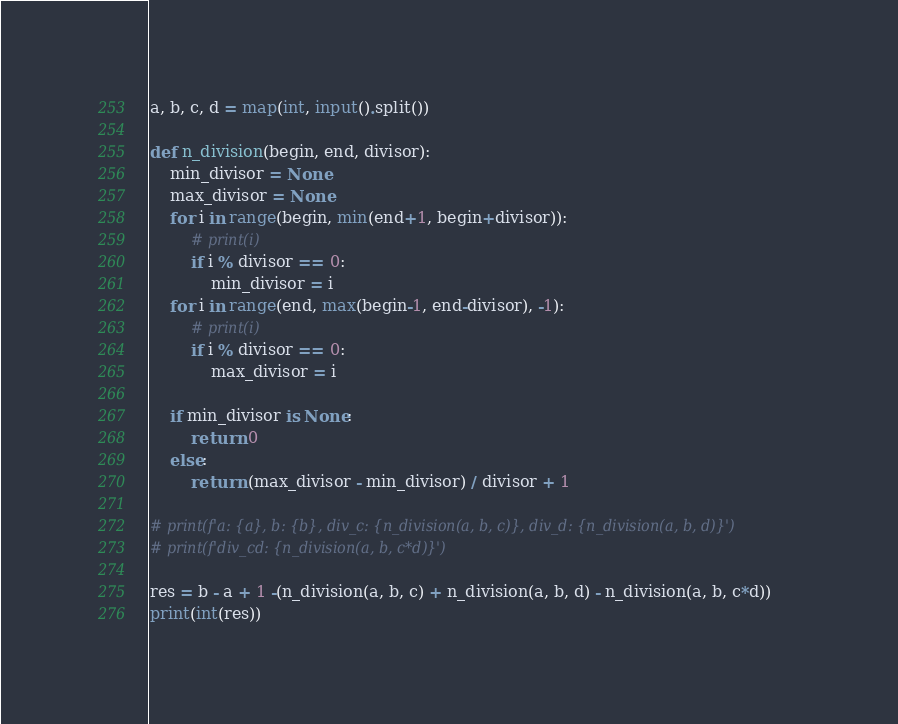Convert code to text. <code><loc_0><loc_0><loc_500><loc_500><_Python_>a, b, c, d = map(int, input().split())

def n_division(begin, end, divisor):
	min_divisor = None
	max_divisor = None
	for i in range(begin, min(end+1, begin+divisor)):
		# print(i)
		if i % divisor == 0:
			min_divisor = i
	for i in range(end, max(begin-1, end-divisor), -1):
		# print(i)
		if i % divisor == 0:
			max_divisor = i
			
	if min_divisor is None:
		return 0
	else:
		return (max_divisor - min_divisor) / divisor + 1 
		
# print(f'a: {a}, b: {b}, div_c: {n_division(a, b, c)}, div_d: {n_division(a, b, d)}')
# print(f'div_cd: {n_division(a, b, c*d)}')
		
res = b - a + 1 -(n_division(a, b, c) + n_division(a, b, d) - n_division(a, b, c*d))
print(int(res))</code> 